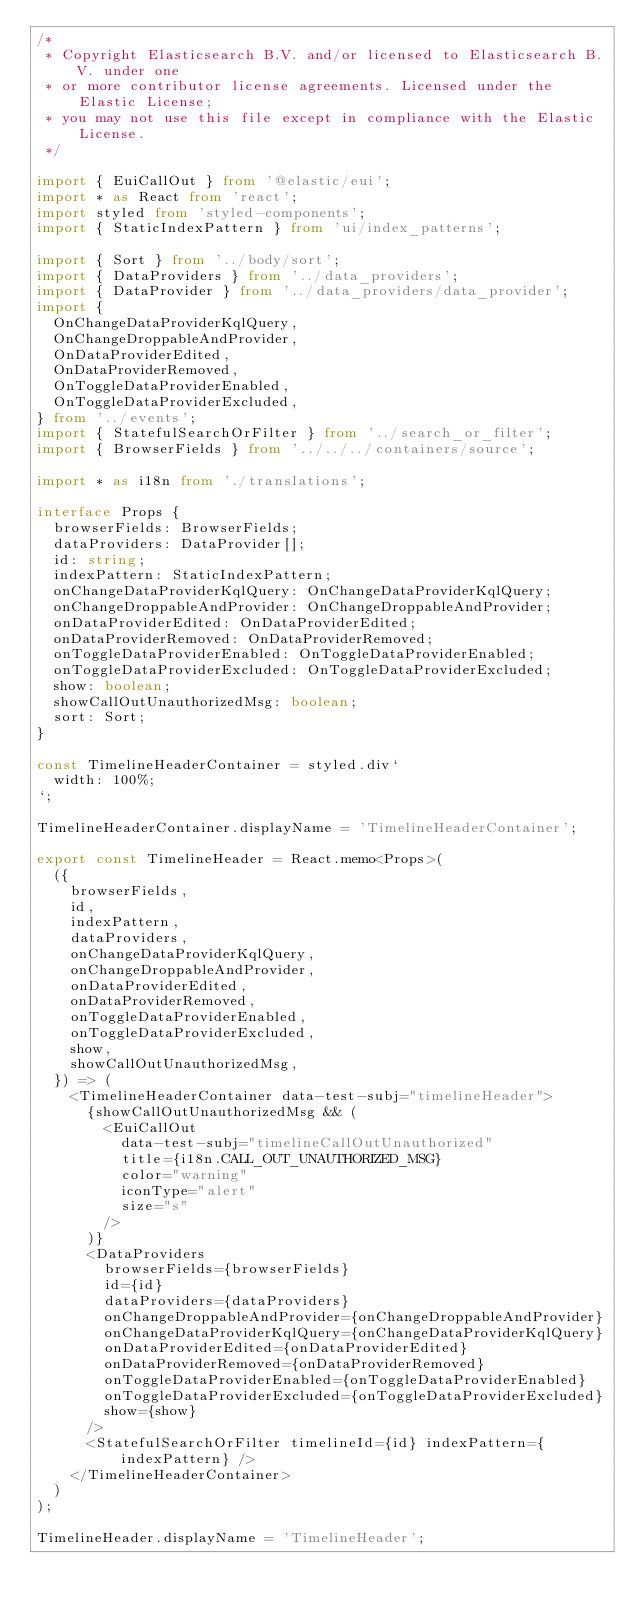Convert code to text. <code><loc_0><loc_0><loc_500><loc_500><_TypeScript_>/*
 * Copyright Elasticsearch B.V. and/or licensed to Elasticsearch B.V. under one
 * or more contributor license agreements. Licensed under the Elastic License;
 * you may not use this file except in compliance with the Elastic License.
 */

import { EuiCallOut } from '@elastic/eui';
import * as React from 'react';
import styled from 'styled-components';
import { StaticIndexPattern } from 'ui/index_patterns';

import { Sort } from '../body/sort';
import { DataProviders } from '../data_providers';
import { DataProvider } from '../data_providers/data_provider';
import {
  OnChangeDataProviderKqlQuery,
  OnChangeDroppableAndProvider,
  OnDataProviderEdited,
  OnDataProviderRemoved,
  OnToggleDataProviderEnabled,
  OnToggleDataProviderExcluded,
} from '../events';
import { StatefulSearchOrFilter } from '../search_or_filter';
import { BrowserFields } from '../../../containers/source';

import * as i18n from './translations';

interface Props {
  browserFields: BrowserFields;
  dataProviders: DataProvider[];
  id: string;
  indexPattern: StaticIndexPattern;
  onChangeDataProviderKqlQuery: OnChangeDataProviderKqlQuery;
  onChangeDroppableAndProvider: OnChangeDroppableAndProvider;
  onDataProviderEdited: OnDataProviderEdited;
  onDataProviderRemoved: OnDataProviderRemoved;
  onToggleDataProviderEnabled: OnToggleDataProviderEnabled;
  onToggleDataProviderExcluded: OnToggleDataProviderExcluded;
  show: boolean;
  showCallOutUnauthorizedMsg: boolean;
  sort: Sort;
}

const TimelineHeaderContainer = styled.div`
  width: 100%;
`;

TimelineHeaderContainer.displayName = 'TimelineHeaderContainer';

export const TimelineHeader = React.memo<Props>(
  ({
    browserFields,
    id,
    indexPattern,
    dataProviders,
    onChangeDataProviderKqlQuery,
    onChangeDroppableAndProvider,
    onDataProviderEdited,
    onDataProviderRemoved,
    onToggleDataProviderEnabled,
    onToggleDataProviderExcluded,
    show,
    showCallOutUnauthorizedMsg,
  }) => (
    <TimelineHeaderContainer data-test-subj="timelineHeader">
      {showCallOutUnauthorizedMsg && (
        <EuiCallOut
          data-test-subj="timelineCallOutUnauthorized"
          title={i18n.CALL_OUT_UNAUTHORIZED_MSG}
          color="warning"
          iconType="alert"
          size="s"
        />
      )}
      <DataProviders
        browserFields={browserFields}
        id={id}
        dataProviders={dataProviders}
        onChangeDroppableAndProvider={onChangeDroppableAndProvider}
        onChangeDataProviderKqlQuery={onChangeDataProviderKqlQuery}
        onDataProviderEdited={onDataProviderEdited}
        onDataProviderRemoved={onDataProviderRemoved}
        onToggleDataProviderEnabled={onToggleDataProviderEnabled}
        onToggleDataProviderExcluded={onToggleDataProviderExcluded}
        show={show}
      />
      <StatefulSearchOrFilter timelineId={id} indexPattern={indexPattern} />
    </TimelineHeaderContainer>
  )
);

TimelineHeader.displayName = 'TimelineHeader';
</code> 